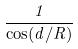<formula> <loc_0><loc_0><loc_500><loc_500>\frac { 1 } { \cos ( d / R ) }</formula> 